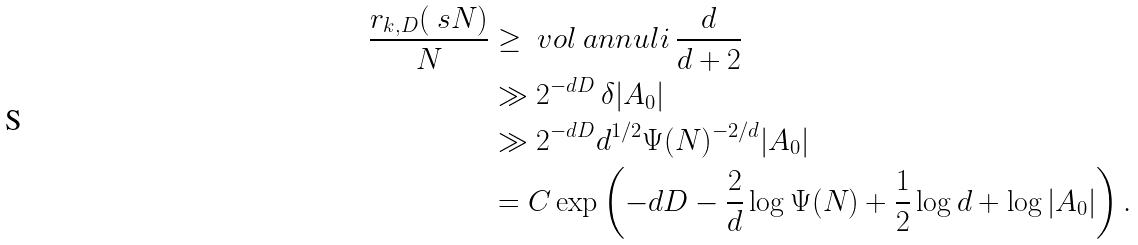Convert formula to latex. <formula><loc_0><loc_0><loc_500><loc_500>\frac { r _ { k , D } ( \ s N ) } { N } & \geq \ v o l \ a n n u l i \, \frac { d } { d + 2 } \\ & \gg 2 ^ { - d D } \, \delta | A _ { 0 } | \\ & \gg 2 ^ { - d D } d ^ { 1 / 2 } \Psi ( N ) ^ { - 2 / d } | A _ { 0 } | \\ & = C \exp \left ( - d D - \frac { 2 } { d } \log \Psi ( N ) + \frac { 1 } { 2 } \log d + \log | A _ { 0 } | \right ) .</formula> 